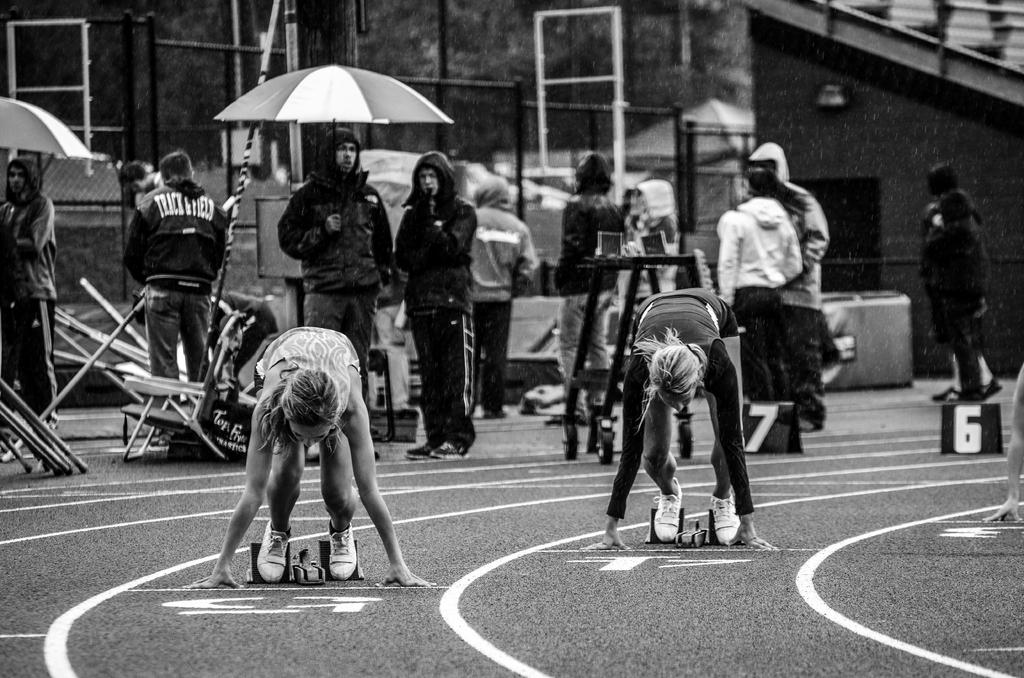What is the color scheme of the image? The image is black and white. How many girls are in the image? There are two girls in the image. What are the girls doing in the image? The girls are in a running competition. Are the girls moving or stationary in the image? The girls are in a steady position, which suggests they are not currently moving. What can be seen in the background of the image? There are many people standing in the background of the image. What type of iron is being used by the girls in the image? There is no iron present in the image; the girls are participating in a running competition. What is the size of the earth as depicted in the image? The image does not depict the earth, and therefore its size cannot be determined from the image. 